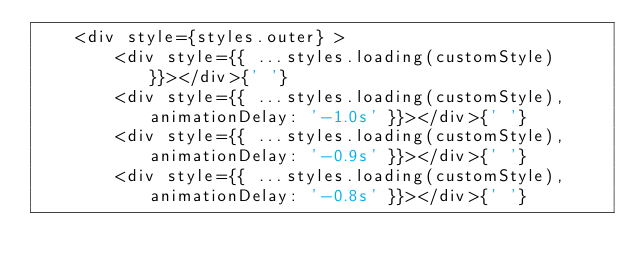<code> <loc_0><loc_0><loc_500><loc_500><_JavaScript_>    <div style={styles.outer} >
        <div style={{ ...styles.loading(customStyle) }}></div>{' '}
        <div style={{ ...styles.loading(customStyle), animationDelay: '-1.0s' }}></div>{' '}
        <div style={{ ...styles.loading(customStyle), animationDelay: '-0.9s' }}></div>{' '}
        <div style={{ ...styles.loading(customStyle), animationDelay: '-0.8s' }}></div>{' '}</code> 